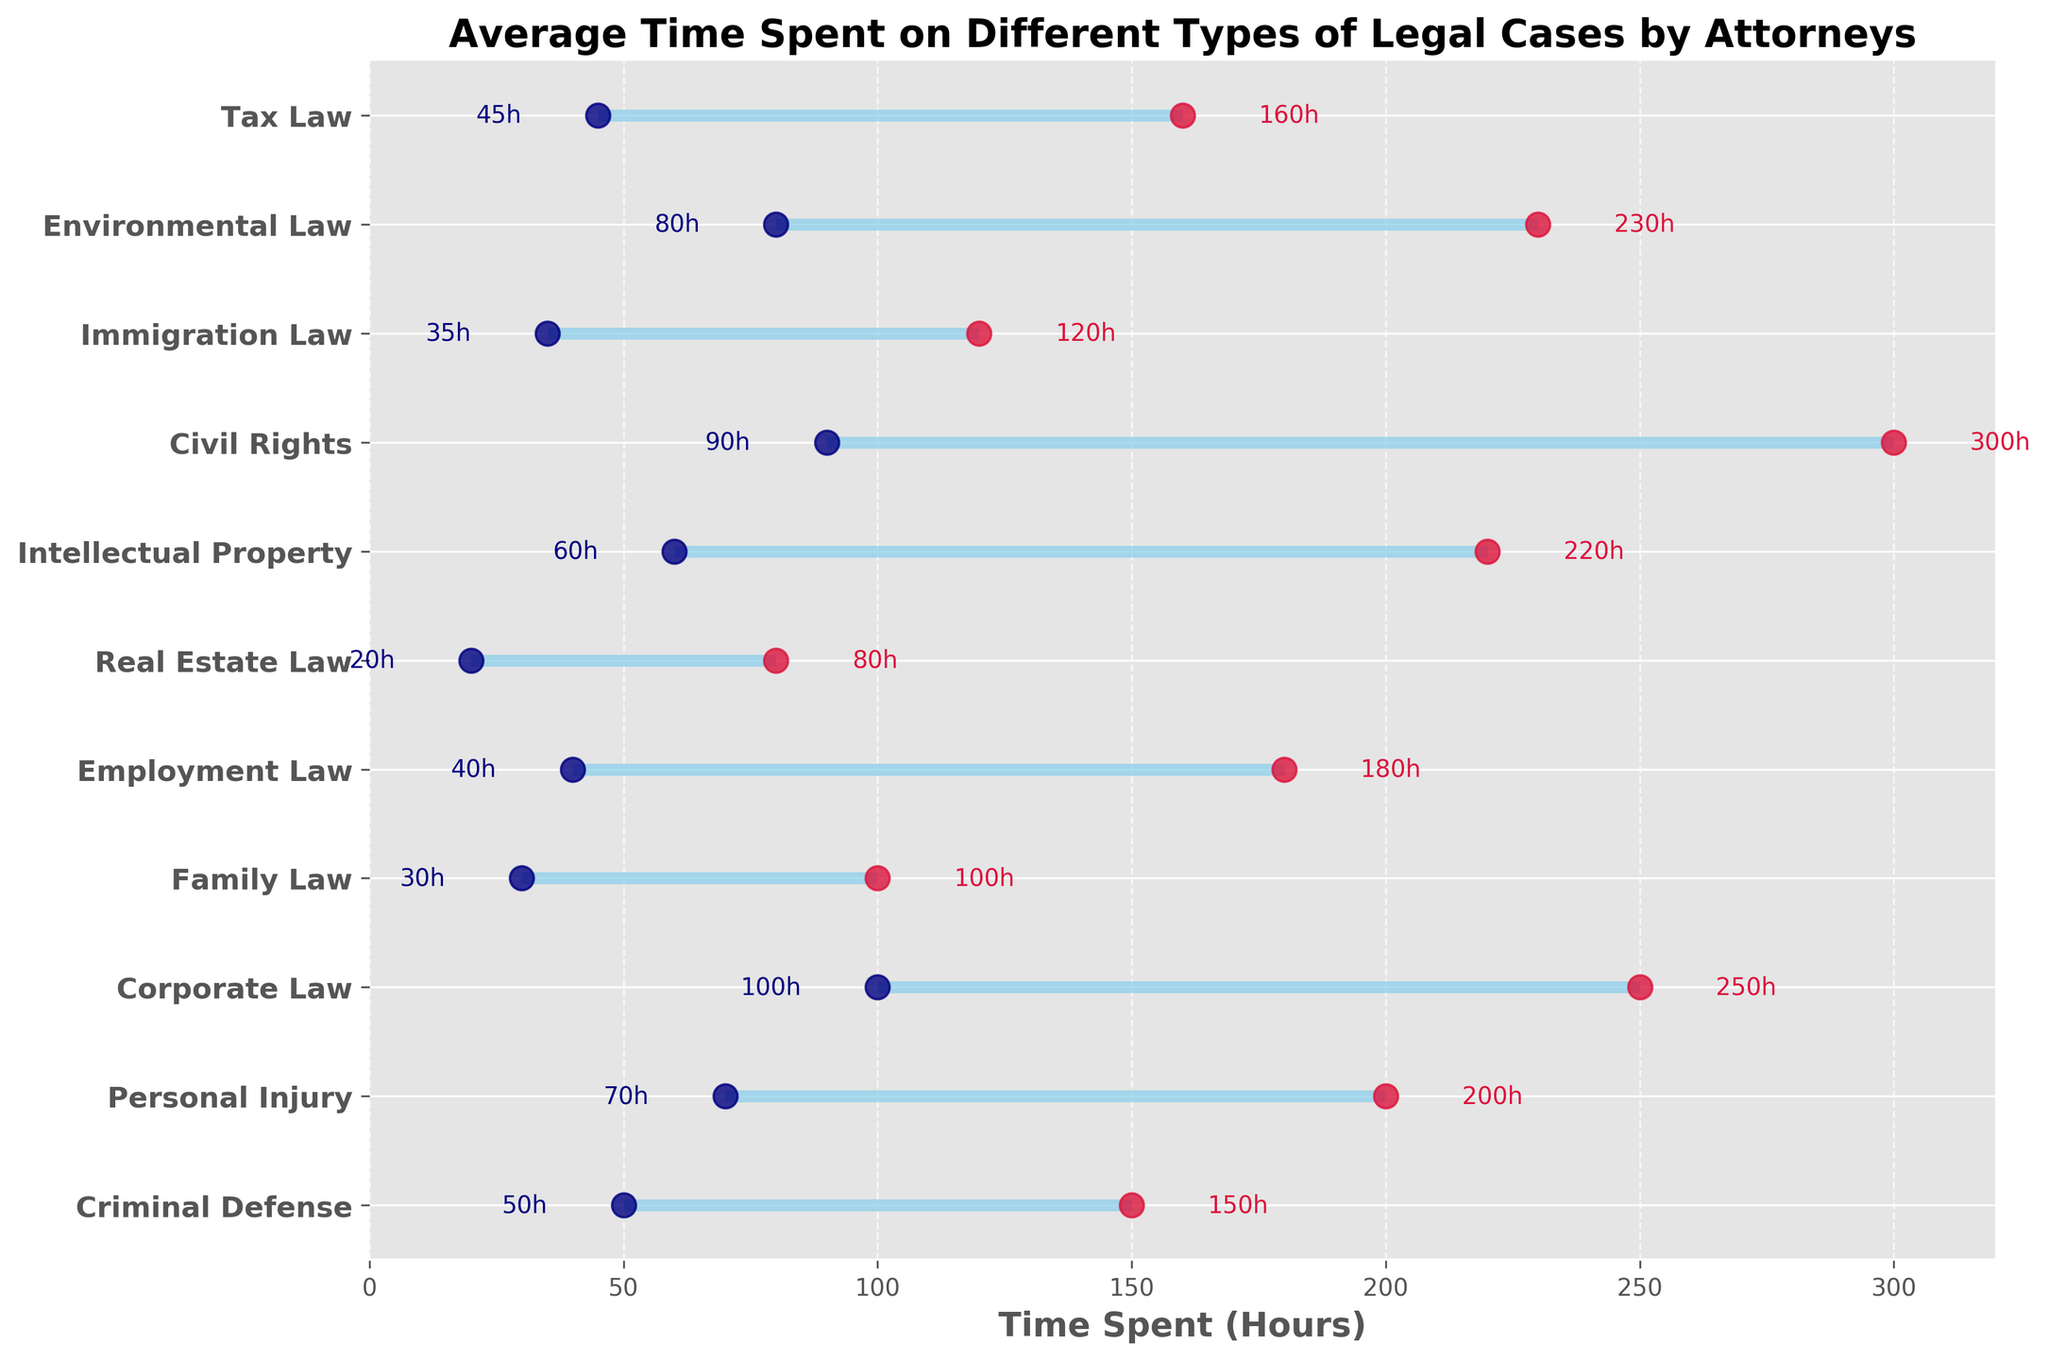What's the title of the plot? The title of the plot is usually shown at the top of the figure, and here it displays the main topic of the visualization.
Answer: Average Time Spent on Different Types of Legal Cases by Attorneys What are the x-axis and y-axis labels? The x-axis label appears below the horizontal axis, and the y-axis label is shown to the left of the vertical axis.
Answer: The x-axis label is "Time Spent (Hours)." The y-axis shows the types of legal cases Which case type has the highest maximum time spent? Locate the highest rightmost point (red dot) on the plot and identify its corresponding case type on the y-axis. The highest red dot is at 300 hours.
Answer: Civil Rights What is the range of time spent on Corporate Law cases? Find the min and max points for Corporate Law on the plot. Corporate Law ranges from 100 hours to 250 hours, hence the range is calculated as 250 - 100.
Answer: 150 hours Which case has the smallest minimum time spent, and what is that value? Locate the leftmost (navy dot) point on the plot and identify its corresponding case type on the y-axis. The leftmost point represents 20 hours.
Answer: Real Estate Law with 20 hours Compare the range of time spent between Criminal Defense and Personal Injury cases. Look at the minimum and maximum times for both case types. Criminal Defense ranges from 50 to 150 hours (range: 100), and Personal Injury ranges from 70 to 200 hours (range: 130).
Answer: Personal Injury has a larger range (130 hours) compared to Criminal Defense (100 hours) Which case types spend at least 200 hours in their maximum time spent? Identify all case types where the red dot (maximum time) is at or above 200 hours. Those case types would be Personal Injury (200h), Corporate Law (250h), Intellectual Property (220h), Civil Rights (300h), Environmental Law (230h).
Answer: Personal Injury, Corporate Law, Intellectual Property, Civil Rights, Environmental Law What's the range of time spent on Tax Law cases compared to Family Law cases? Tax Law ranges from 45 to 160 hours, equaling a range of 115 hours. Family Law ranges from 30 to 100 hours, equaling a range of 70 hours.
Answer: Tax Law has a larger range (115 hours) compared to Family Law (70 hours) What's the approximate average maximum time spent on all case types? Sum the maximum times for all case types and divide by the number of case types. (150 + 200 + 250 + 100 + 180 + 80 + 220 + 300 + 120 + 230 + 160) / 11 ≈ 1189 / 11.
Answer: Approximately 108.1 hours 